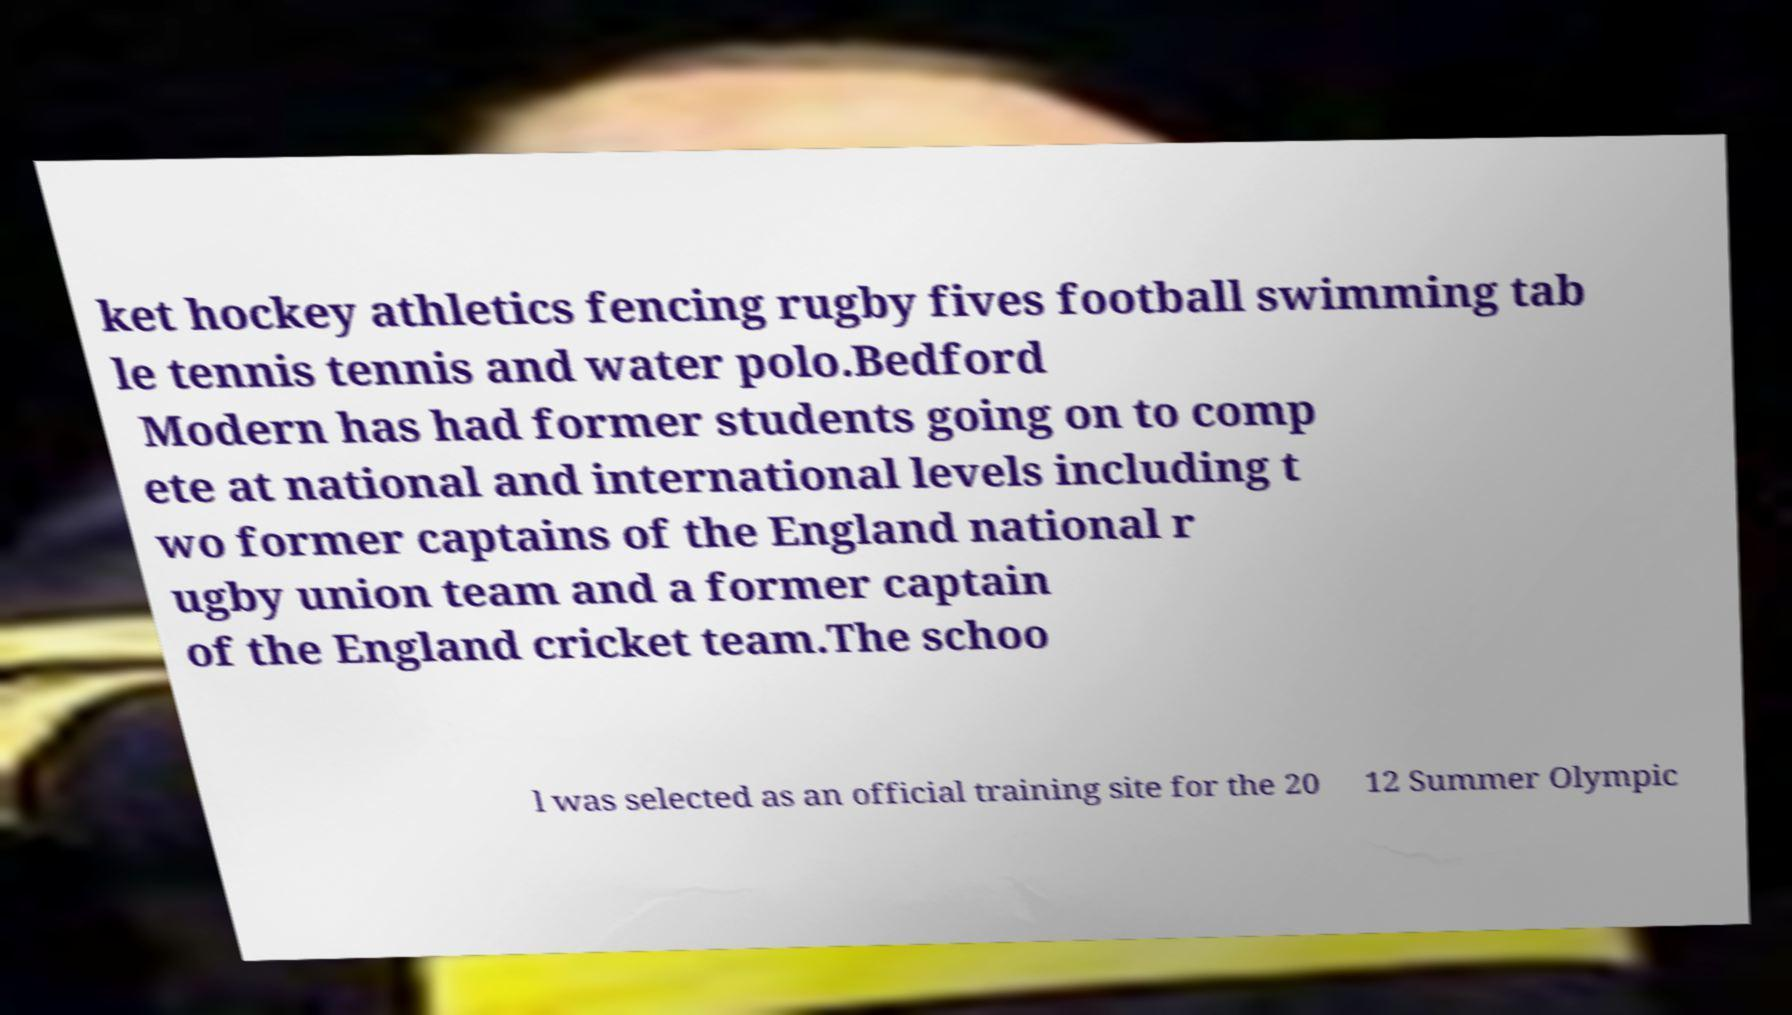Could you extract and type out the text from this image? ket hockey athletics fencing rugby fives football swimming tab le tennis tennis and water polo.Bedford Modern has had former students going on to comp ete at national and international levels including t wo former captains of the England national r ugby union team and a former captain of the England cricket team.The schoo l was selected as an official training site for the 20 12 Summer Olympic 